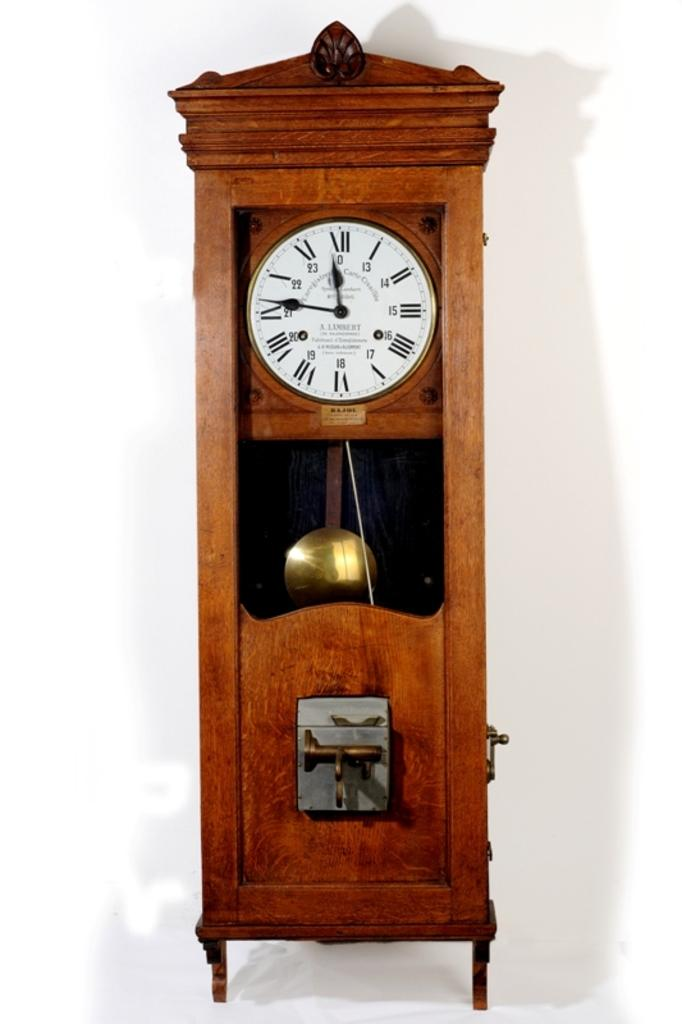<image>
Share a concise interpretation of the image provided. An antique style wall clock that is displaying the time of 11:46. 